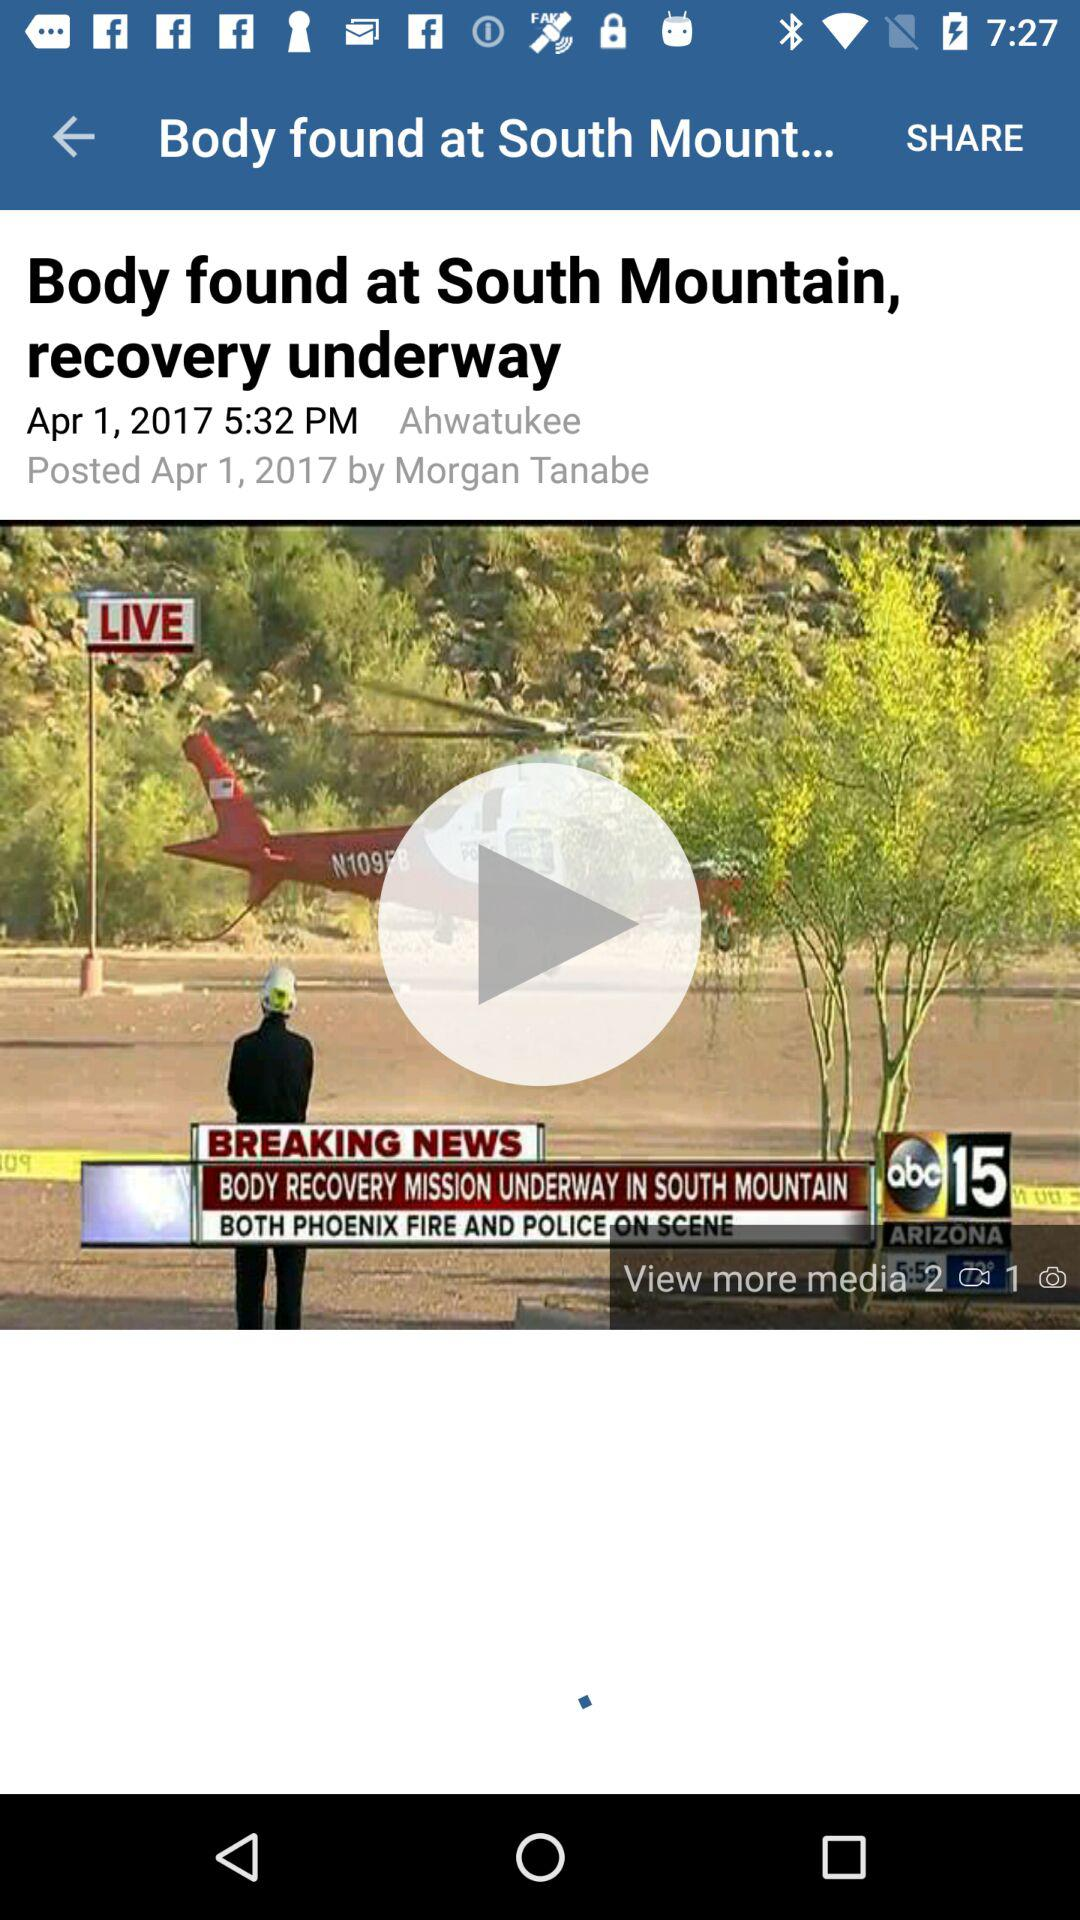At what time was the news posted? The news was posted at 5:32 PM. 